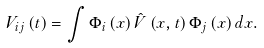<formula> <loc_0><loc_0><loc_500><loc_500>V _ { i j } \left ( t \right ) = \int { \Phi _ { i } \left ( x \right ) \hat { V } \left ( { x , t } \right ) \Phi _ { j } \left ( x \right ) d x } .</formula> 